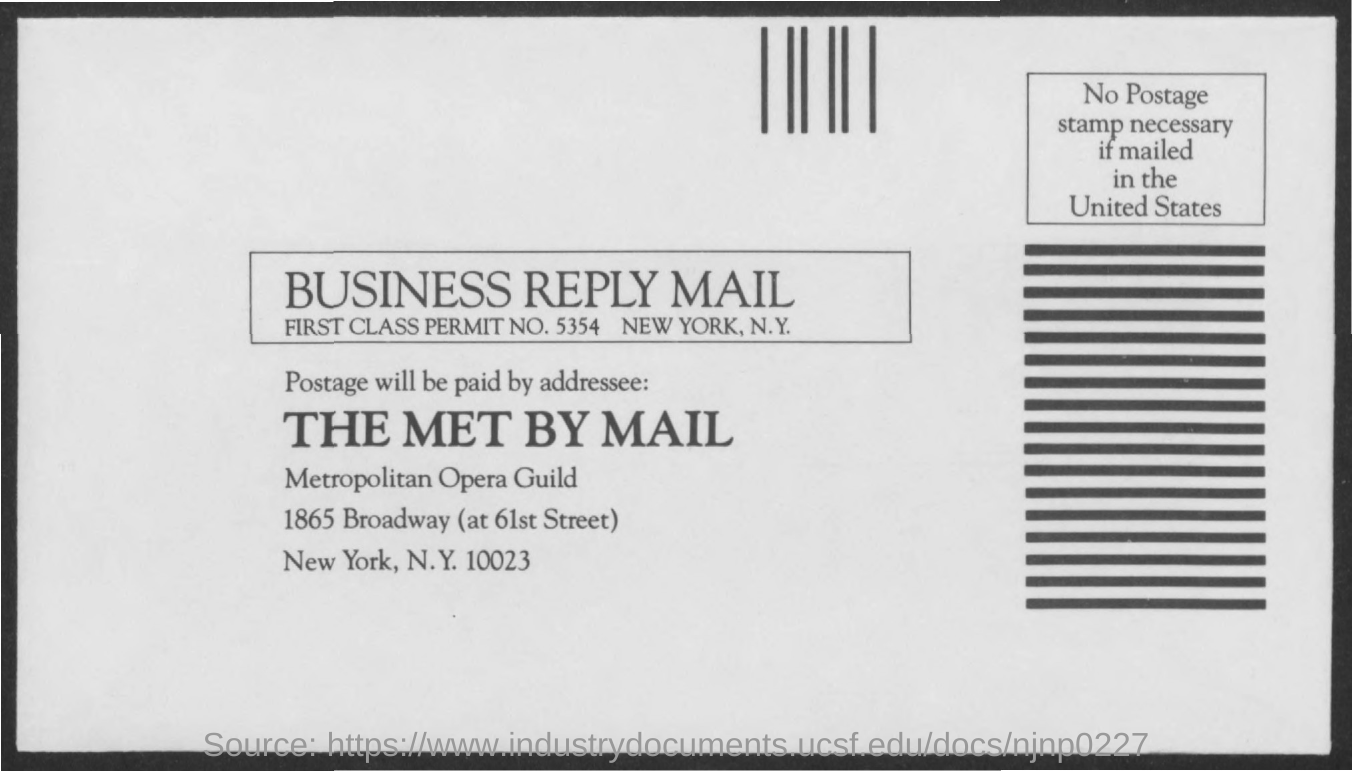What is the First class permit no. mentioned here?
Provide a succinct answer. 5354. 